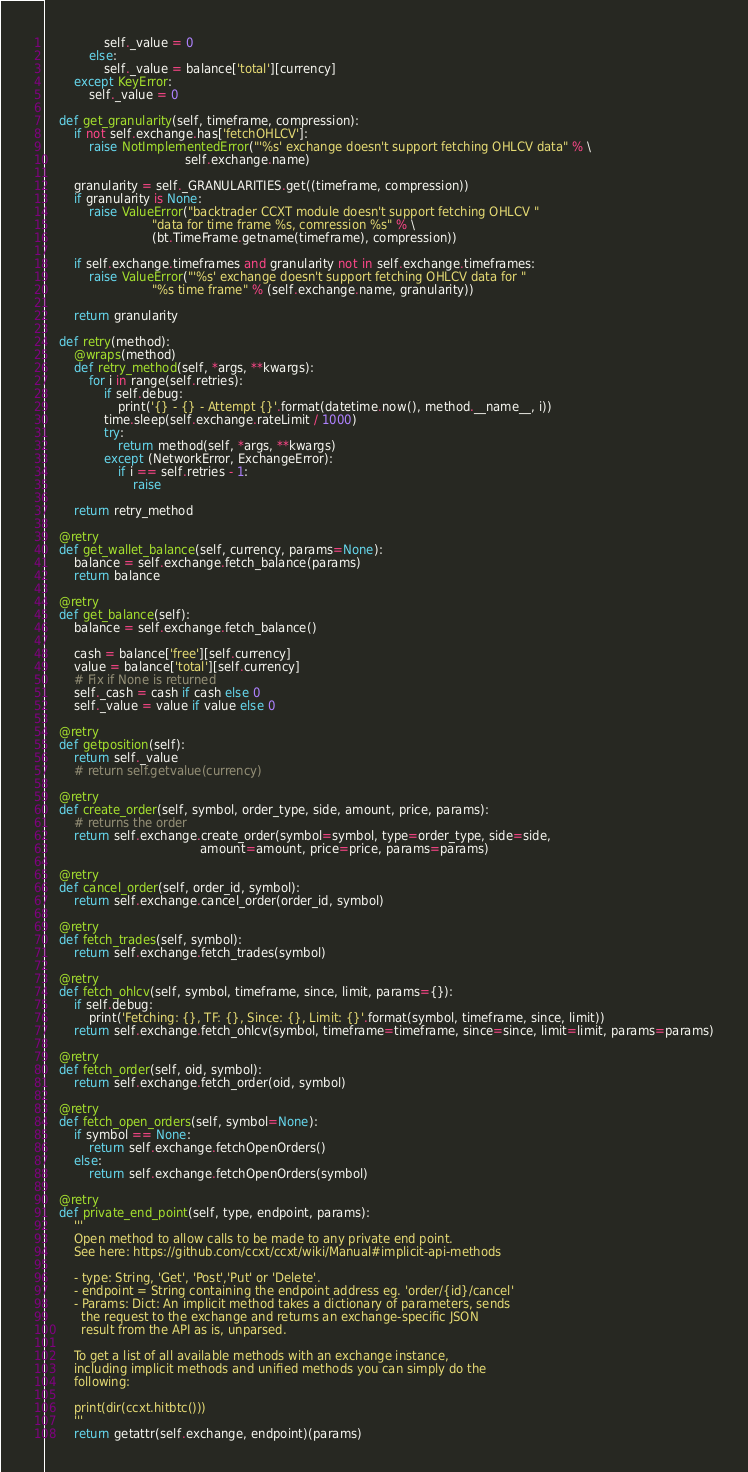Convert code to text. <code><loc_0><loc_0><loc_500><loc_500><_Python_>                self._value = 0
            else:
                self._value = balance['total'][currency]
        except KeyError:
            self._value = 0

    def get_granularity(self, timeframe, compression):
        if not self.exchange.has['fetchOHLCV']:
            raise NotImplementedError("'%s' exchange doesn't support fetching OHLCV data" % \
                                      self.exchange.name)

        granularity = self._GRANULARITIES.get((timeframe, compression))
        if granularity is None:
            raise ValueError("backtrader CCXT module doesn't support fetching OHLCV "
                             "data for time frame %s, comression %s" % \
                             (bt.TimeFrame.getname(timeframe), compression))

        if self.exchange.timeframes and granularity not in self.exchange.timeframes:
            raise ValueError("'%s' exchange doesn't support fetching OHLCV data for "
                             "%s time frame" % (self.exchange.name, granularity))

        return granularity

    def retry(method):
        @wraps(method)
        def retry_method(self, *args, **kwargs):
            for i in range(self.retries):
                if self.debug:
                    print('{} - {} - Attempt {}'.format(datetime.now(), method.__name__, i))
                time.sleep(self.exchange.rateLimit / 1000)
                try:
                    return method(self, *args, **kwargs)
                except (NetworkError, ExchangeError):
                    if i == self.retries - 1:
                        raise

        return retry_method

    @retry
    def get_wallet_balance(self, currency, params=None):
        balance = self.exchange.fetch_balance(params)
        return balance

    @retry
    def get_balance(self):
        balance = self.exchange.fetch_balance()

        cash = balance['free'][self.currency]
        value = balance['total'][self.currency]
        # Fix if None is returned
        self._cash = cash if cash else 0
        self._value = value if value else 0

    @retry
    def getposition(self):
        return self._value
        # return self.getvalue(currency)

    @retry
    def create_order(self, symbol, order_type, side, amount, price, params):
        # returns the order
        return self.exchange.create_order(symbol=symbol, type=order_type, side=side,
                                          amount=amount, price=price, params=params)

    @retry
    def cancel_order(self, order_id, symbol):
        return self.exchange.cancel_order(order_id, symbol)

    @retry
    def fetch_trades(self, symbol):
        return self.exchange.fetch_trades(symbol)

    @retry
    def fetch_ohlcv(self, symbol, timeframe, since, limit, params={}):
        if self.debug:
            print('Fetching: {}, TF: {}, Since: {}, Limit: {}'.format(symbol, timeframe, since, limit))
        return self.exchange.fetch_ohlcv(symbol, timeframe=timeframe, since=since, limit=limit, params=params)

    @retry
    def fetch_order(self, oid, symbol):
        return self.exchange.fetch_order(oid, symbol)

    @retry
    def fetch_open_orders(self, symbol=None):
        if symbol == None:
            return self.exchange.fetchOpenOrders()
        else:
            return self.exchange.fetchOpenOrders(symbol)

    @retry
    def private_end_point(self, type, endpoint, params):
        '''
        Open method to allow calls to be made to any private end point.
        See here: https://github.com/ccxt/ccxt/wiki/Manual#implicit-api-methods

        - type: String, 'Get', 'Post','Put' or 'Delete'.
        - endpoint = String containing the endpoint address eg. 'order/{id}/cancel'
        - Params: Dict: An implicit method takes a dictionary of parameters, sends
          the request to the exchange and returns an exchange-specific JSON
          result from the API as is, unparsed.

        To get a list of all available methods with an exchange instance,
        including implicit methods and unified methods you can simply do the
        following:

        print(dir(ccxt.hitbtc()))
        '''
        return getattr(self.exchange, endpoint)(params)
</code> 